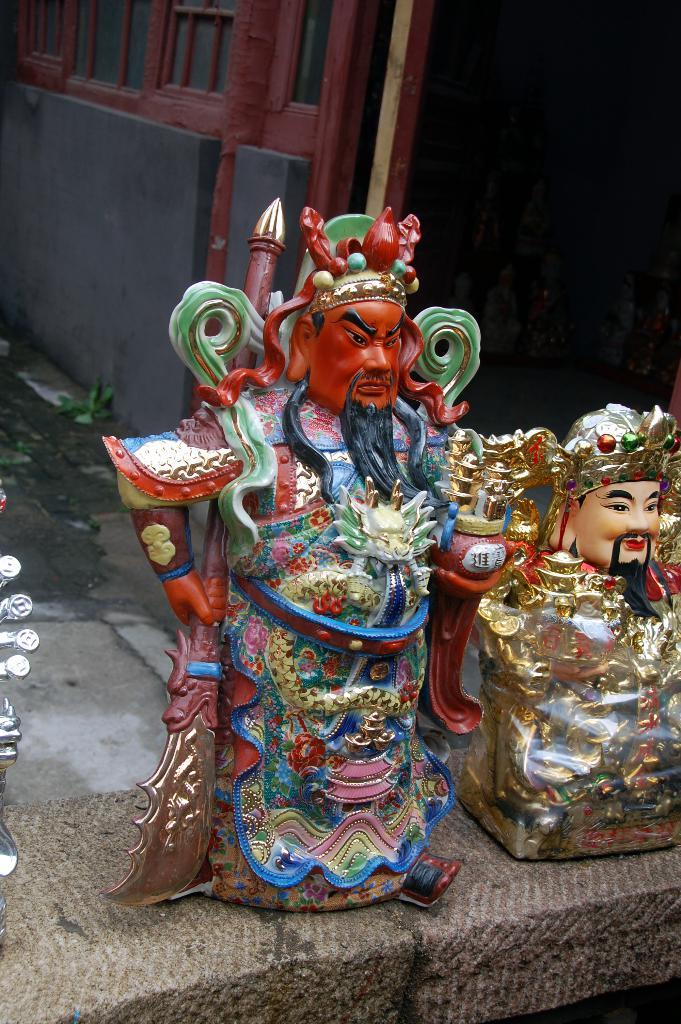How many statues are present in the image? There are two statues in the image. Where are the statues located? The statues are kept on the floor. What can be seen in the background of the image? There is a wall in the background of the image. What type of sign is held by one of the statues in the image? There is no sign present in the image; the statues are not holding anything. 